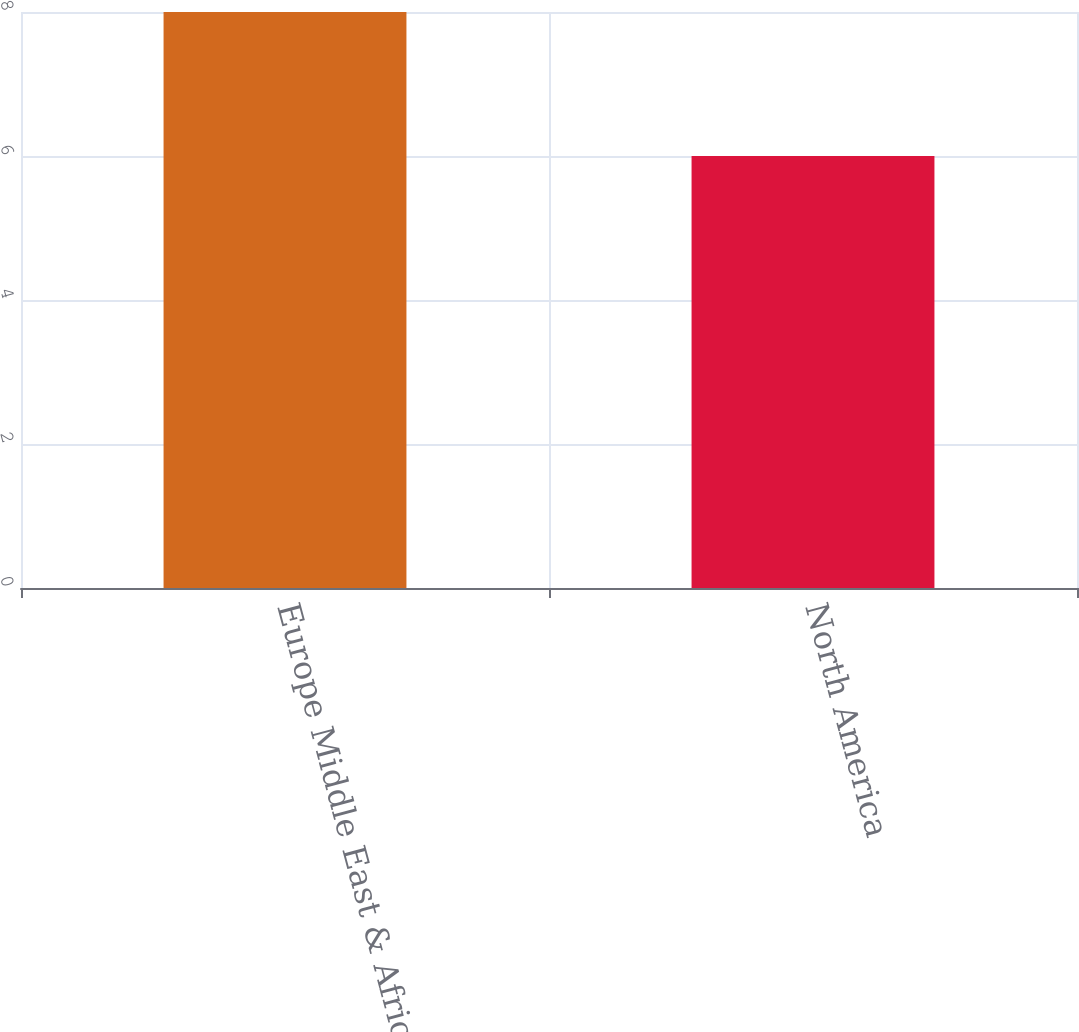Convert chart to OTSL. <chart><loc_0><loc_0><loc_500><loc_500><bar_chart><fcel>Europe Middle East & Africa<fcel>North America<nl><fcel>8<fcel>6<nl></chart> 